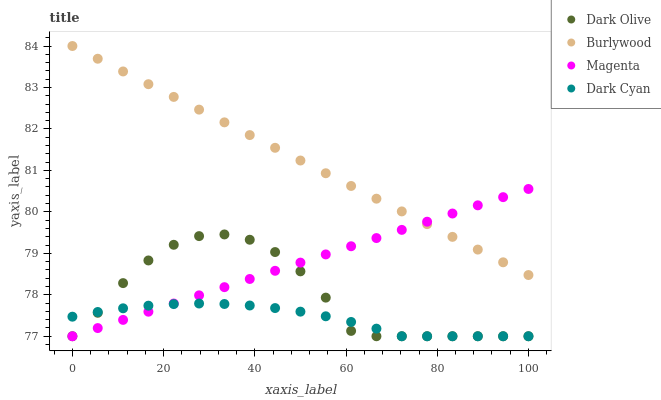Does Dark Cyan have the minimum area under the curve?
Answer yes or no. Yes. Does Burlywood have the maximum area under the curve?
Answer yes or no. Yes. Does Magenta have the minimum area under the curve?
Answer yes or no. No. Does Magenta have the maximum area under the curve?
Answer yes or no. No. Is Magenta the smoothest?
Answer yes or no. Yes. Is Dark Olive the roughest?
Answer yes or no. Yes. Is Dark Cyan the smoothest?
Answer yes or no. No. Is Dark Cyan the roughest?
Answer yes or no. No. Does Dark Cyan have the lowest value?
Answer yes or no. Yes. Does Burlywood have the highest value?
Answer yes or no. Yes. Does Magenta have the highest value?
Answer yes or no. No. Is Dark Olive less than Burlywood?
Answer yes or no. Yes. Is Burlywood greater than Dark Olive?
Answer yes or no. Yes. Does Dark Olive intersect Magenta?
Answer yes or no. Yes. Is Dark Olive less than Magenta?
Answer yes or no. No. Is Dark Olive greater than Magenta?
Answer yes or no. No. Does Dark Olive intersect Burlywood?
Answer yes or no. No. 